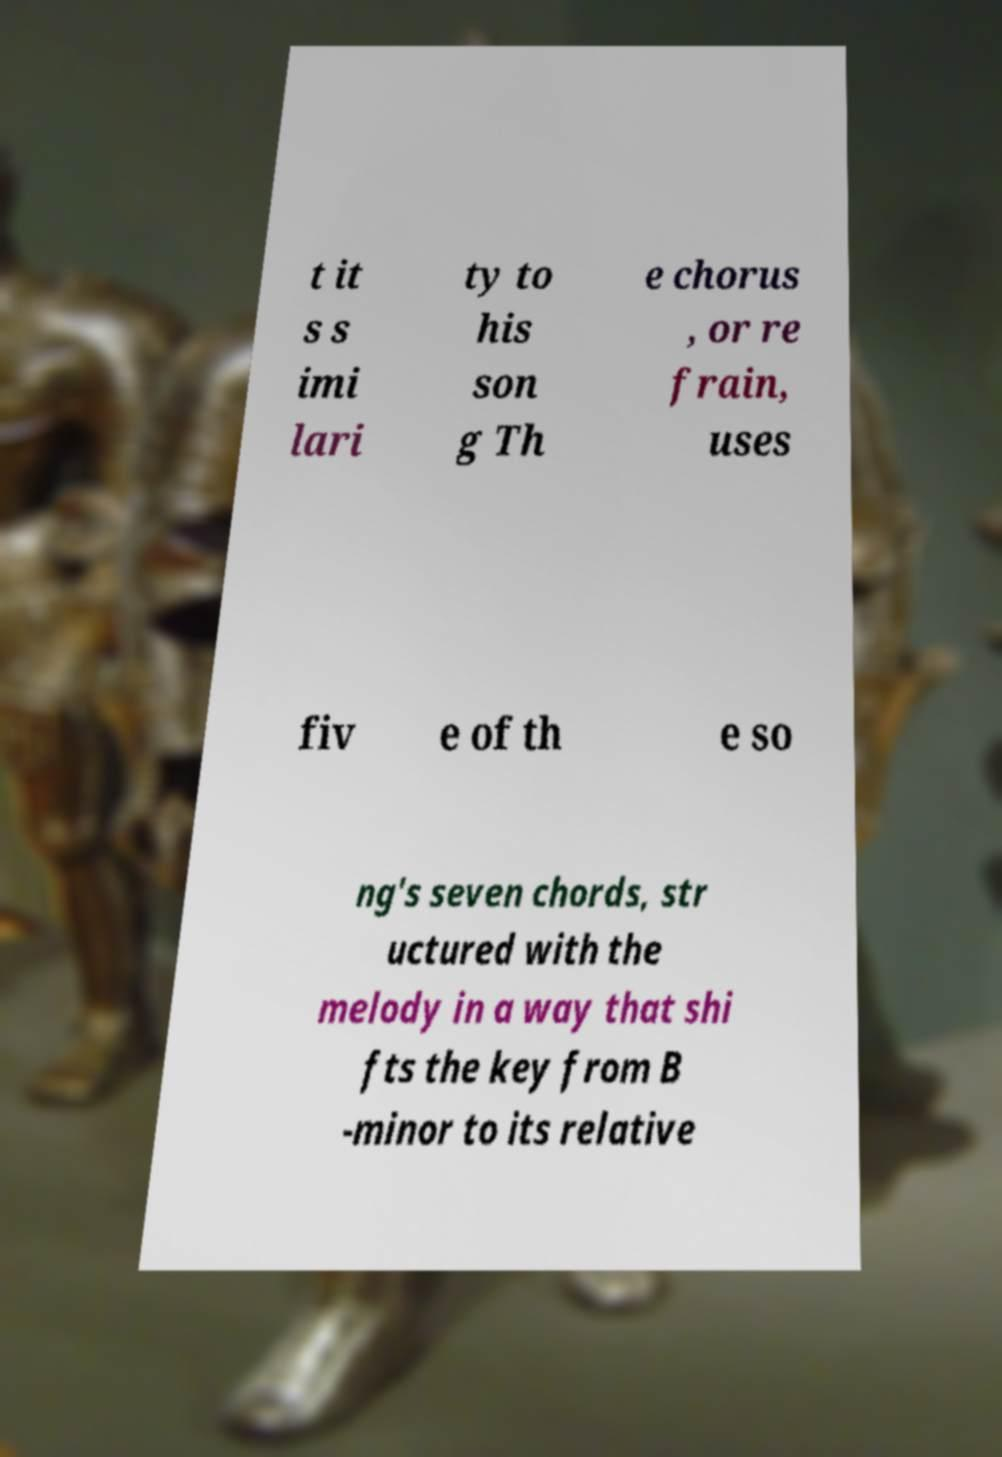Can you read and provide the text displayed in the image?This photo seems to have some interesting text. Can you extract and type it out for me? t it s s imi lari ty to his son g Th e chorus , or re frain, uses fiv e of th e so ng's seven chords, str uctured with the melody in a way that shi fts the key from B -minor to its relative 